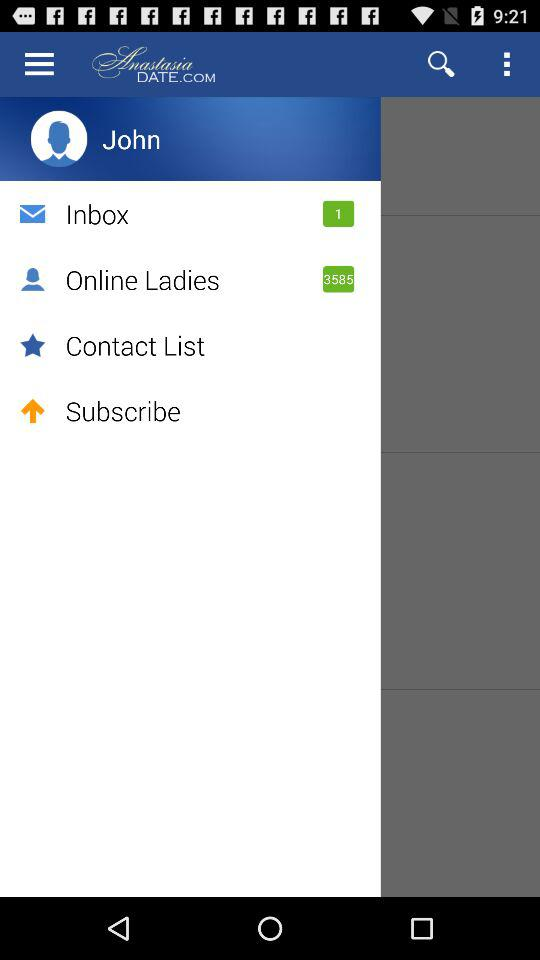How many messages are unread? There is 1 unread message. 